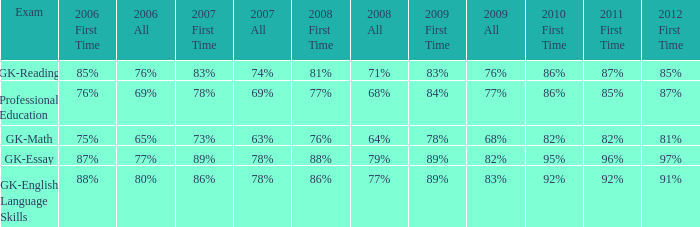What is the percentage for first time in 2012 when it was 82% for all in 2009? 97%. 